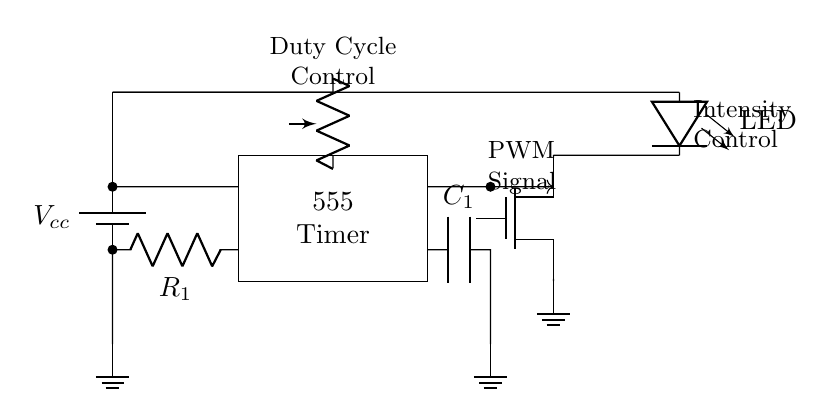What is the power supply voltage in this circuit? The power supply voltage is denoted as Vcc in the circuit diagram, indicating the positive voltage provided to the circuit.
Answer: Vcc What component is used to control the LED intensity? The LED intensity is controlled by the Pulse Width Modulation (PWM) signal generated by the 555 Timer, which adjusts the power delivered to the LED based on the duty cycle.
Answer: PWM signal What is the function of the capacitor in this circuit? The capacitor (C1) in the circuit helps filter the PWM signal, smoothing it out to reduce flicker in the LED intensity, providing a more stable output.
Answer: Smoothing PWM signal How does the potentiometer affect the circuit? The potentiometer adjusts the resistance in the circuit, thereby altering the duty cycle of the PWM signal generated by the 555 Timer, which in turn changes the intensity of the LED.
Answer: Adjusts duty cycle What type of transistor is used in this circuit? The circuit uses an N-channel MOSFET, which is suitable for switching applications and allows for higher current flow to the LED when activated by the PWM signal.
Answer: N-channel MOSFET How does the duty cycle of the PWM signal relate to LED brightness? The duty cycle determines the portion of time the LED is on versus off; a higher duty cycle means the LED is on for a longer time, resulting in greater brightness, while a lower duty cycle reduces brightness.
Answer: Directly proportional 